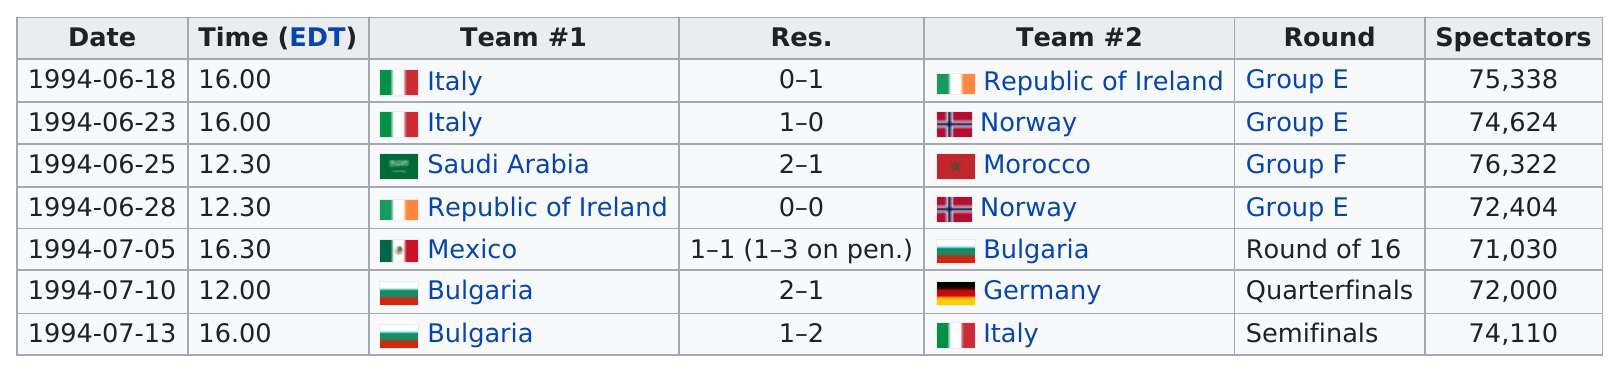Specify some key components in this picture. After June 28, 1994, there were three matches. The Republic of Ireland was the first team to defeat Italy. The team that did not win the match with 75,338 spectators was Italy. In the 1994 FIFA World Cup match between Italy and the Republic of Ireland, Italy scored two additional total goals compared to the Republic of Ireland. The difference in the number of spectators between the best attended match and the least attended match of all matches listed is 5,292. 